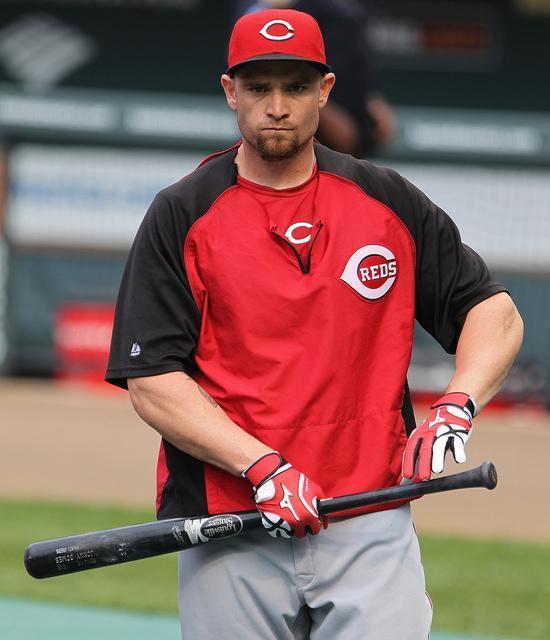How many people are in the photo?
Give a very brief answer. 2. How many baseball gloves can be seen?
Give a very brief answer. 2. 